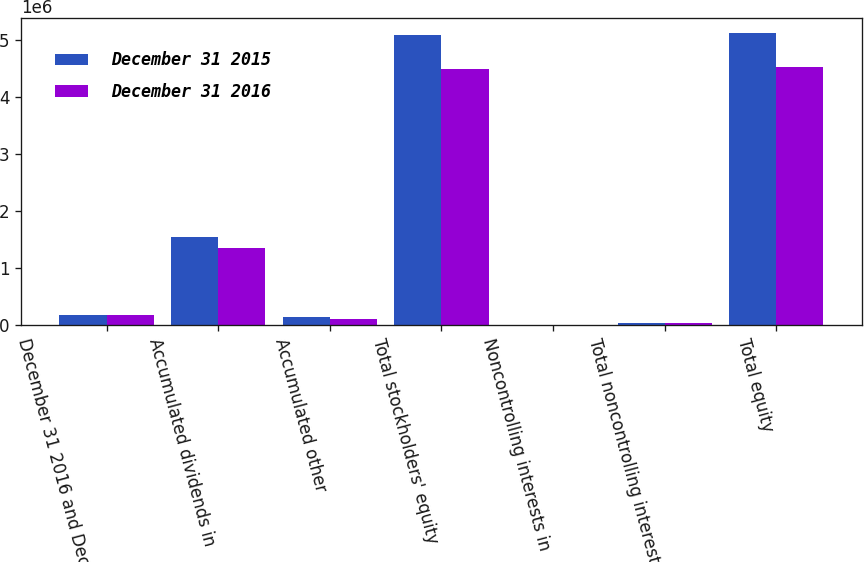Convert chart. <chart><loc_0><loc_0><loc_500><loc_500><stacked_bar_chart><ecel><fcel>December 31 2016 and December<fcel>Accumulated dividends in<fcel>Accumulated other<fcel>Total stockholders' equity<fcel>Noncontrolling interests in<fcel>Total noncontrolling interests<fcel>Total equity<nl><fcel>December 31 2015<fcel>176191<fcel>1.54742e+06<fcel>135605<fcel>5.09602e+06<fcel>6598<fcel>36282<fcel>5.1323e+06<nl><fcel>December 31 2016<fcel>176191<fcel>1.35009e+06<fcel>96590<fcel>4.50013e+06<fcel>6758<fcel>36370<fcel>4.5365e+06<nl></chart> 